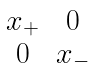Convert formula to latex. <formula><loc_0><loc_0><loc_500><loc_500>\begin{matrix} x _ { + } & 0 \\ 0 & x _ { - } \end{matrix}</formula> 